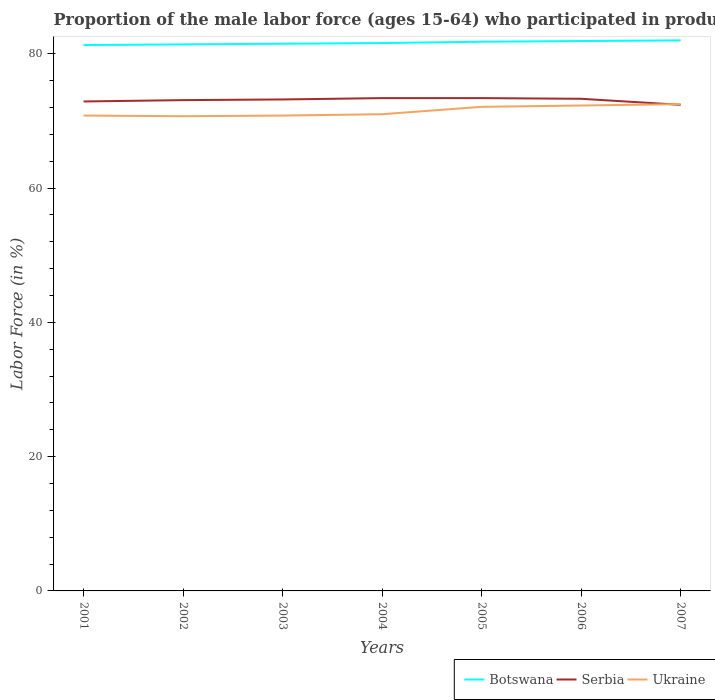How many different coloured lines are there?
Give a very brief answer. 3. Does the line corresponding to Botswana intersect with the line corresponding to Serbia?
Offer a terse response. No. Across all years, what is the maximum proportion of the male labor force who participated in production in Botswana?
Ensure brevity in your answer.  81.3. In which year was the proportion of the male labor force who participated in production in Botswana maximum?
Your response must be concise. 2001. What is the total proportion of the male labor force who participated in production in Ukraine in the graph?
Offer a terse response. -0.1. What is the difference between the highest and the second highest proportion of the male labor force who participated in production in Serbia?
Your answer should be very brief. 1. What is the difference between the highest and the lowest proportion of the male labor force who participated in production in Botswana?
Give a very brief answer. 3. Is the proportion of the male labor force who participated in production in Botswana strictly greater than the proportion of the male labor force who participated in production in Serbia over the years?
Provide a short and direct response. No. How many lines are there?
Offer a terse response. 3. How many years are there in the graph?
Your answer should be very brief. 7. Does the graph contain any zero values?
Keep it short and to the point. No. How many legend labels are there?
Offer a very short reply. 3. How are the legend labels stacked?
Your answer should be compact. Horizontal. What is the title of the graph?
Ensure brevity in your answer.  Proportion of the male labor force (ages 15-64) who participated in production. What is the label or title of the Y-axis?
Your response must be concise. Labor Force (in %). What is the Labor Force (in %) in Botswana in 2001?
Give a very brief answer. 81.3. What is the Labor Force (in %) in Serbia in 2001?
Keep it short and to the point. 72.9. What is the Labor Force (in %) of Ukraine in 2001?
Ensure brevity in your answer.  70.8. What is the Labor Force (in %) in Botswana in 2002?
Offer a terse response. 81.4. What is the Labor Force (in %) in Serbia in 2002?
Provide a short and direct response. 73.1. What is the Labor Force (in %) in Ukraine in 2002?
Provide a succinct answer. 70.7. What is the Labor Force (in %) in Botswana in 2003?
Give a very brief answer. 81.5. What is the Labor Force (in %) of Serbia in 2003?
Offer a terse response. 73.2. What is the Labor Force (in %) of Ukraine in 2003?
Provide a succinct answer. 70.8. What is the Labor Force (in %) of Botswana in 2004?
Make the answer very short. 81.6. What is the Labor Force (in %) in Serbia in 2004?
Provide a short and direct response. 73.4. What is the Labor Force (in %) in Ukraine in 2004?
Your answer should be very brief. 71. What is the Labor Force (in %) of Botswana in 2005?
Offer a terse response. 81.8. What is the Labor Force (in %) in Serbia in 2005?
Keep it short and to the point. 73.4. What is the Labor Force (in %) in Ukraine in 2005?
Offer a very short reply. 72.1. What is the Labor Force (in %) in Botswana in 2006?
Offer a terse response. 81.9. What is the Labor Force (in %) in Serbia in 2006?
Your answer should be compact. 73.3. What is the Labor Force (in %) of Ukraine in 2006?
Provide a succinct answer. 72.3. What is the Labor Force (in %) of Serbia in 2007?
Give a very brief answer. 72.4. What is the Labor Force (in %) in Ukraine in 2007?
Provide a succinct answer. 72.5. Across all years, what is the maximum Labor Force (in %) in Serbia?
Your response must be concise. 73.4. Across all years, what is the maximum Labor Force (in %) in Ukraine?
Your answer should be compact. 72.5. Across all years, what is the minimum Labor Force (in %) in Botswana?
Keep it short and to the point. 81.3. Across all years, what is the minimum Labor Force (in %) of Serbia?
Offer a terse response. 72.4. Across all years, what is the minimum Labor Force (in %) of Ukraine?
Your answer should be very brief. 70.7. What is the total Labor Force (in %) in Botswana in the graph?
Provide a succinct answer. 571.5. What is the total Labor Force (in %) of Serbia in the graph?
Provide a short and direct response. 511.7. What is the total Labor Force (in %) of Ukraine in the graph?
Offer a very short reply. 500.2. What is the difference between the Labor Force (in %) in Botswana in 2001 and that in 2002?
Your response must be concise. -0.1. What is the difference between the Labor Force (in %) of Ukraine in 2001 and that in 2002?
Provide a succinct answer. 0.1. What is the difference between the Labor Force (in %) in Botswana in 2001 and that in 2003?
Give a very brief answer. -0.2. What is the difference between the Labor Force (in %) of Serbia in 2001 and that in 2003?
Give a very brief answer. -0.3. What is the difference between the Labor Force (in %) of Ukraine in 2001 and that in 2003?
Provide a succinct answer. 0. What is the difference between the Labor Force (in %) of Serbia in 2001 and that in 2004?
Provide a succinct answer. -0.5. What is the difference between the Labor Force (in %) of Botswana in 2001 and that in 2005?
Provide a succinct answer. -0.5. What is the difference between the Labor Force (in %) in Serbia in 2001 and that in 2005?
Provide a succinct answer. -0.5. What is the difference between the Labor Force (in %) in Botswana in 2001 and that in 2006?
Provide a short and direct response. -0.6. What is the difference between the Labor Force (in %) in Botswana in 2001 and that in 2007?
Your answer should be very brief. -0.7. What is the difference between the Labor Force (in %) of Serbia in 2001 and that in 2007?
Your response must be concise. 0.5. What is the difference between the Labor Force (in %) of Ukraine in 2001 and that in 2007?
Your answer should be compact. -1.7. What is the difference between the Labor Force (in %) of Serbia in 2002 and that in 2004?
Offer a very short reply. -0.3. What is the difference between the Labor Force (in %) in Ukraine in 2002 and that in 2004?
Your answer should be very brief. -0.3. What is the difference between the Labor Force (in %) of Serbia in 2002 and that in 2005?
Make the answer very short. -0.3. What is the difference between the Labor Force (in %) of Botswana in 2002 and that in 2006?
Your answer should be very brief. -0.5. What is the difference between the Labor Force (in %) of Serbia in 2002 and that in 2006?
Your answer should be very brief. -0.2. What is the difference between the Labor Force (in %) of Botswana in 2002 and that in 2007?
Provide a succinct answer. -0.6. What is the difference between the Labor Force (in %) of Serbia in 2002 and that in 2007?
Ensure brevity in your answer.  0.7. What is the difference between the Labor Force (in %) of Ukraine in 2002 and that in 2007?
Your response must be concise. -1.8. What is the difference between the Labor Force (in %) of Serbia in 2003 and that in 2004?
Your answer should be compact. -0.2. What is the difference between the Labor Force (in %) in Ukraine in 2003 and that in 2004?
Provide a short and direct response. -0.2. What is the difference between the Labor Force (in %) of Ukraine in 2003 and that in 2005?
Ensure brevity in your answer.  -1.3. What is the difference between the Labor Force (in %) of Botswana in 2003 and that in 2006?
Your answer should be compact. -0.4. What is the difference between the Labor Force (in %) of Serbia in 2003 and that in 2006?
Provide a short and direct response. -0.1. What is the difference between the Labor Force (in %) in Botswana in 2003 and that in 2007?
Keep it short and to the point. -0.5. What is the difference between the Labor Force (in %) of Ukraine in 2003 and that in 2007?
Your response must be concise. -1.7. What is the difference between the Labor Force (in %) of Serbia in 2004 and that in 2005?
Keep it short and to the point. 0. What is the difference between the Labor Force (in %) of Serbia in 2004 and that in 2007?
Your answer should be compact. 1. What is the difference between the Labor Force (in %) of Botswana in 2005 and that in 2006?
Provide a succinct answer. -0.1. What is the difference between the Labor Force (in %) of Serbia in 2005 and that in 2006?
Make the answer very short. 0.1. What is the difference between the Labor Force (in %) in Ukraine in 2005 and that in 2006?
Provide a short and direct response. -0.2. What is the difference between the Labor Force (in %) of Botswana in 2005 and that in 2007?
Give a very brief answer. -0.2. What is the difference between the Labor Force (in %) in Serbia in 2005 and that in 2007?
Provide a succinct answer. 1. What is the difference between the Labor Force (in %) of Botswana in 2006 and that in 2007?
Your answer should be compact. -0.1. What is the difference between the Labor Force (in %) in Botswana in 2001 and the Labor Force (in %) in Serbia in 2002?
Provide a succinct answer. 8.2. What is the difference between the Labor Force (in %) of Botswana in 2001 and the Labor Force (in %) of Ukraine in 2002?
Your answer should be very brief. 10.6. What is the difference between the Labor Force (in %) of Serbia in 2001 and the Labor Force (in %) of Ukraine in 2002?
Offer a terse response. 2.2. What is the difference between the Labor Force (in %) in Botswana in 2001 and the Labor Force (in %) in Serbia in 2003?
Your answer should be compact. 8.1. What is the difference between the Labor Force (in %) in Botswana in 2001 and the Labor Force (in %) in Ukraine in 2003?
Make the answer very short. 10.5. What is the difference between the Labor Force (in %) in Serbia in 2001 and the Labor Force (in %) in Ukraine in 2003?
Provide a succinct answer. 2.1. What is the difference between the Labor Force (in %) in Botswana in 2001 and the Labor Force (in %) in Serbia in 2004?
Your answer should be compact. 7.9. What is the difference between the Labor Force (in %) of Botswana in 2001 and the Labor Force (in %) of Ukraine in 2005?
Offer a very short reply. 9.2. What is the difference between the Labor Force (in %) of Botswana in 2001 and the Labor Force (in %) of Serbia in 2006?
Offer a terse response. 8. What is the difference between the Labor Force (in %) of Serbia in 2001 and the Labor Force (in %) of Ukraine in 2006?
Provide a short and direct response. 0.6. What is the difference between the Labor Force (in %) of Botswana in 2001 and the Labor Force (in %) of Serbia in 2007?
Your answer should be very brief. 8.9. What is the difference between the Labor Force (in %) of Botswana in 2002 and the Labor Force (in %) of Serbia in 2003?
Your response must be concise. 8.2. What is the difference between the Labor Force (in %) in Botswana in 2002 and the Labor Force (in %) in Ukraine in 2003?
Make the answer very short. 10.6. What is the difference between the Labor Force (in %) of Botswana in 2002 and the Labor Force (in %) of Serbia in 2004?
Give a very brief answer. 8. What is the difference between the Labor Force (in %) in Botswana in 2002 and the Labor Force (in %) in Ukraine in 2004?
Ensure brevity in your answer.  10.4. What is the difference between the Labor Force (in %) of Botswana in 2002 and the Labor Force (in %) of Ukraine in 2006?
Provide a short and direct response. 9.1. What is the difference between the Labor Force (in %) in Serbia in 2002 and the Labor Force (in %) in Ukraine in 2007?
Offer a very short reply. 0.6. What is the difference between the Labor Force (in %) in Serbia in 2003 and the Labor Force (in %) in Ukraine in 2004?
Your response must be concise. 2.2. What is the difference between the Labor Force (in %) of Botswana in 2003 and the Labor Force (in %) of Serbia in 2005?
Your answer should be very brief. 8.1. What is the difference between the Labor Force (in %) of Botswana in 2003 and the Labor Force (in %) of Ukraine in 2006?
Your answer should be compact. 9.2. What is the difference between the Labor Force (in %) in Botswana in 2003 and the Labor Force (in %) in Serbia in 2007?
Your answer should be very brief. 9.1. What is the difference between the Labor Force (in %) of Serbia in 2003 and the Labor Force (in %) of Ukraine in 2007?
Offer a terse response. 0.7. What is the difference between the Labor Force (in %) of Botswana in 2004 and the Labor Force (in %) of Serbia in 2006?
Your answer should be very brief. 8.3. What is the difference between the Labor Force (in %) in Botswana in 2004 and the Labor Force (in %) in Ukraine in 2006?
Provide a short and direct response. 9.3. What is the difference between the Labor Force (in %) in Serbia in 2004 and the Labor Force (in %) in Ukraine in 2006?
Make the answer very short. 1.1. What is the difference between the Labor Force (in %) in Botswana in 2004 and the Labor Force (in %) in Ukraine in 2007?
Offer a terse response. 9.1. What is the difference between the Labor Force (in %) in Botswana in 2005 and the Labor Force (in %) in Ukraine in 2006?
Provide a succinct answer. 9.5. What is the difference between the Labor Force (in %) in Botswana in 2006 and the Labor Force (in %) in Ukraine in 2007?
Ensure brevity in your answer.  9.4. What is the difference between the Labor Force (in %) in Serbia in 2006 and the Labor Force (in %) in Ukraine in 2007?
Keep it short and to the point. 0.8. What is the average Labor Force (in %) in Botswana per year?
Offer a very short reply. 81.64. What is the average Labor Force (in %) of Serbia per year?
Make the answer very short. 73.1. What is the average Labor Force (in %) in Ukraine per year?
Provide a succinct answer. 71.46. In the year 2002, what is the difference between the Labor Force (in %) of Botswana and Labor Force (in %) of Serbia?
Your answer should be compact. 8.3. In the year 2002, what is the difference between the Labor Force (in %) in Botswana and Labor Force (in %) in Ukraine?
Give a very brief answer. 10.7. In the year 2002, what is the difference between the Labor Force (in %) in Serbia and Labor Force (in %) in Ukraine?
Your answer should be compact. 2.4. In the year 2003, what is the difference between the Labor Force (in %) in Serbia and Labor Force (in %) in Ukraine?
Your response must be concise. 2.4. In the year 2004, what is the difference between the Labor Force (in %) in Botswana and Labor Force (in %) in Serbia?
Your answer should be very brief. 8.2. In the year 2004, what is the difference between the Labor Force (in %) in Botswana and Labor Force (in %) in Ukraine?
Your answer should be very brief. 10.6. In the year 2005, what is the difference between the Labor Force (in %) of Serbia and Labor Force (in %) of Ukraine?
Your answer should be very brief. 1.3. In the year 2006, what is the difference between the Labor Force (in %) in Botswana and Labor Force (in %) in Ukraine?
Provide a short and direct response. 9.6. In the year 2006, what is the difference between the Labor Force (in %) in Serbia and Labor Force (in %) in Ukraine?
Give a very brief answer. 1. In the year 2007, what is the difference between the Labor Force (in %) of Botswana and Labor Force (in %) of Ukraine?
Ensure brevity in your answer.  9.5. What is the ratio of the Labor Force (in %) in Serbia in 2001 to that in 2002?
Your answer should be compact. 1. What is the ratio of the Labor Force (in %) in Botswana in 2001 to that in 2003?
Your response must be concise. 1. What is the ratio of the Labor Force (in %) of Serbia in 2001 to that in 2003?
Offer a terse response. 1. What is the ratio of the Labor Force (in %) of Serbia in 2001 to that in 2004?
Keep it short and to the point. 0.99. What is the ratio of the Labor Force (in %) in Ukraine in 2001 to that in 2004?
Your response must be concise. 1. What is the ratio of the Labor Force (in %) in Ukraine in 2001 to that in 2005?
Ensure brevity in your answer.  0.98. What is the ratio of the Labor Force (in %) of Ukraine in 2001 to that in 2006?
Your answer should be compact. 0.98. What is the ratio of the Labor Force (in %) in Serbia in 2001 to that in 2007?
Provide a succinct answer. 1.01. What is the ratio of the Labor Force (in %) in Ukraine in 2001 to that in 2007?
Provide a succinct answer. 0.98. What is the ratio of the Labor Force (in %) of Botswana in 2002 to that in 2003?
Provide a succinct answer. 1. What is the ratio of the Labor Force (in %) of Serbia in 2002 to that in 2003?
Your response must be concise. 1. What is the ratio of the Labor Force (in %) of Ukraine in 2002 to that in 2003?
Give a very brief answer. 1. What is the ratio of the Labor Force (in %) in Botswana in 2002 to that in 2004?
Ensure brevity in your answer.  1. What is the ratio of the Labor Force (in %) of Ukraine in 2002 to that in 2004?
Your response must be concise. 1. What is the ratio of the Labor Force (in %) in Botswana in 2002 to that in 2005?
Your response must be concise. 1. What is the ratio of the Labor Force (in %) in Serbia in 2002 to that in 2005?
Provide a short and direct response. 1. What is the ratio of the Labor Force (in %) in Ukraine in 2002 to that in 2005?
Offer a very short reply. 0.98. What is the ratio of the Labor Force (in %) of Botswana in 2002 to that in 2006?
Make the answer very short. 0.99. What is the ratio of the Labor Force (in %) of Ukraine in 2002 to that in 2006?
Provide a succinct answer. 0.98. What is the ratio of the Labor Force (in %) in Botswana in 2002 to that in 2007?
Your response must be concise. 0.99. What is the ratio of the Labor Force (in %) in Serbia in 2002 to that in 2007?
Your answer should be very brief. 1.01. What is the ratio of the Labor Force (in %) in Ukraine in 2002 to that in 2007?
Provide a short and direct response. 0.98. What is the ratio of the Labor Force (in %) in Botswana in 2003 to that in 2004?
Your response must be concise. 1. What is the ratio of the Labor Force (in %) of Ukraine in 2003 to that in 2004?
Offer a very short reply. 1. What is the ratio of the Labor Force (in %) in Serbia in 2003 to that in 2005?
Keep it short and to the point. 1. What is the ratio of the Labor Force (in %) in Ukraine in 2003 to that in 2006?
Make the answer very short. 0.98. What is the ratio of the Labor Force (in %) of Botswana in 2003 to that in 2007?
Offer a terse response. 0.99. What is the ratio of the Labor Force (in %) of Ukraine in 2003 to that in 2007?
Make the answer very short. 0.98. What is the ratio of the Labor Force (in %) in Botswana in 2004 to that in 2005?
Ensure brevity in your answer.  1. What is the ratio of the Labor Force (in %) in Ukraine in 2004 to that in 2005?
Your response must be concise. 0.98. What is the ratio of the Labor Force (in %) in Ukraine in 2004 to that in 2006?
Offer a terse response. 0.98. What is the ratio of the Labor Force (in %) of Botswana in 2004 to that in 2007?
Ensure brevity in your answer.  1. What is the ratio of the Labor Force (in %) in Serbia in 2004 to that in 2007?
Make the answer very short. 1.01. What is the ratio of the Labor Force (in %) of Ukraine in 2004 to that in 2007?
Your answer should be compact. 0.98. What is the ratio of the Labor Force (in %) of Botswana in 2005 to that in 2006?
Your response must be concise. 1. What is the ratio of the Labor Force (in %) of Serbia in 2005 to that in 2006?
Your answer should be compact. 1. What is the ratio of the Labor Force (in %) of Ukraine in 2005 to that in 2006?
Provide a succinct answer. 1. What is the ratio of the Labor Force (in %) in Botswana in 2005 to that in 2007?
Provide a short and direct response. 1. What is the ratio of the Labor Force (in %) of Serbia in 2005 to that in 2007?
Provide a succinct answer. 1.01. What is the ratio of the Labor Force (in %) of Ukraine in 2005 to that in 2007?
Make the answer very short. 0.99. What is the ratio of the Labor Force (in %) in Serbia in 2006 to that in 2007?
Keep it short and to the point. 1.01. What is the difference between the highest and the second highest Labor Force (in %) of Botswana?
Offer a very short reply. 0.1. What is the difference between the highest and the second highest Labor Force (in %) in Serbia?
Keep it short and to the point. 0. What is the difference between the highest and the second highest Labor Force (in %) of Ukraine?
Provide a succinct answer. 0.2. 